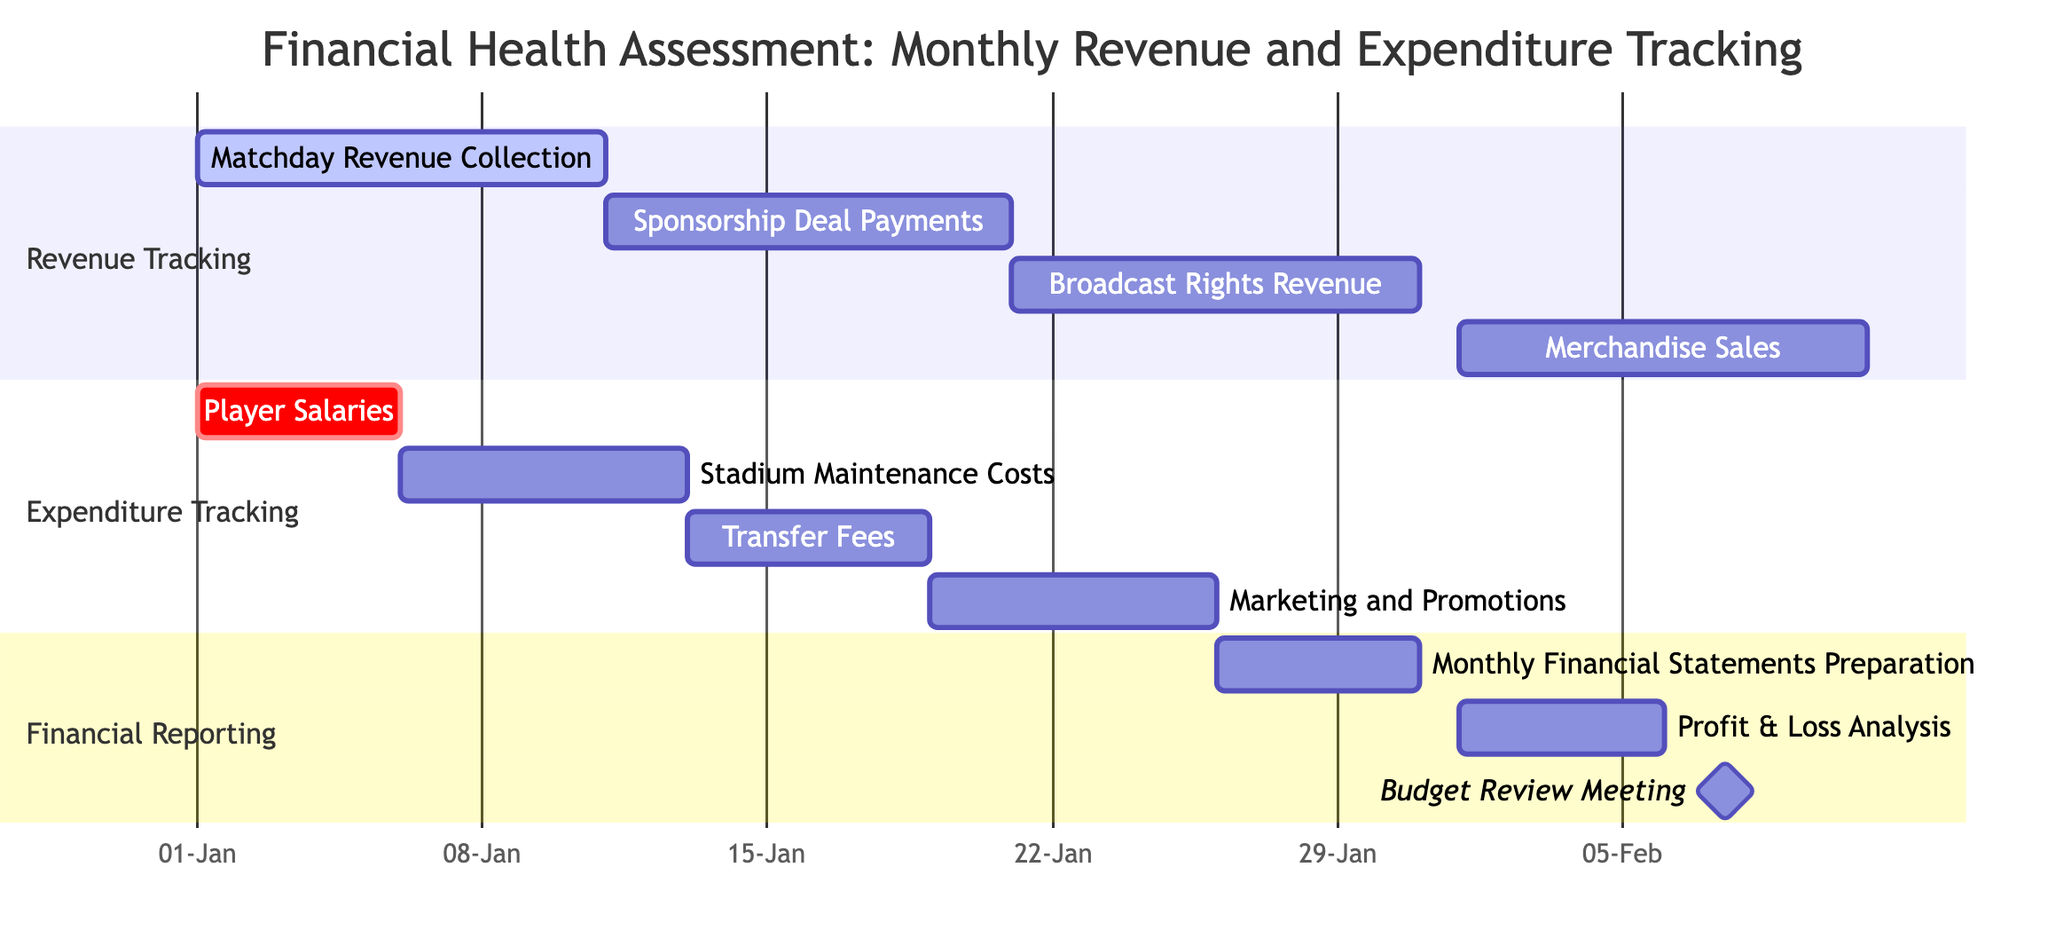What is the duration of Matchday Revenue Collection? The task starts on January 1st and ends on January 10th. Therefore, the duration is 10 days.
Answer: 10 days Which task in Expenditure Tracking has the earliest end date? The tasks in Expenditure Tracking are Player Salaries (January 5), Stadium Maintenance Costs (January 12), Transfer Fees (January 18), and Marketing and Promotions (January 25). Player Salaries ends first on January 5th.
Answer: Player Salaries How many tasks are listed under Financial Reporting? The section Financial Reporting contains three tasks: Monthly Financial Statements Preparation, Profit & Loss Analysis, and Budget Review Meeting. Therefore, there are three tasks.
Answer: 3 What is the start date of the Sponsorship Deal Payments task? The Sponsorship Deal Payments task starts on January 11th. This information is directly available in the diagram.
Answer: January 11 Which expenditure task overlaps with Merchandise Sales? Merchandise Sales starts on February 1st and ends on February 10th. The Profit & Loss Analysis task also starts on February 1st and ends on February 5th, overlapping with Merchandise Sales.
Answer: Profit & Loss Analysis How many days does the Stadium Maintenance Costs task last? The task starts on January 6th and ends on January 12th, which gives a duration of 7 days.
Answer: 7 days What is the relationship between Player Salaries and Marketing and Promotions? Player Salaries starts on January 1st and ends on January 5th, while Marketing and Promotions starts on January 19th and ends on January 25th. They do not overlap.
Answer: No overlap What is the last date of the Monthly Financial Statements Preparation task? This task runs from January 26th to January 30th, thus the last date is January 30th.
Answer: January 30 Which task marks a milestone in the Financial Reporting section? The Budget Review Meeting is labeled as a milestone in the Financial Reporting section.
Answer: Budget Review Meeting 